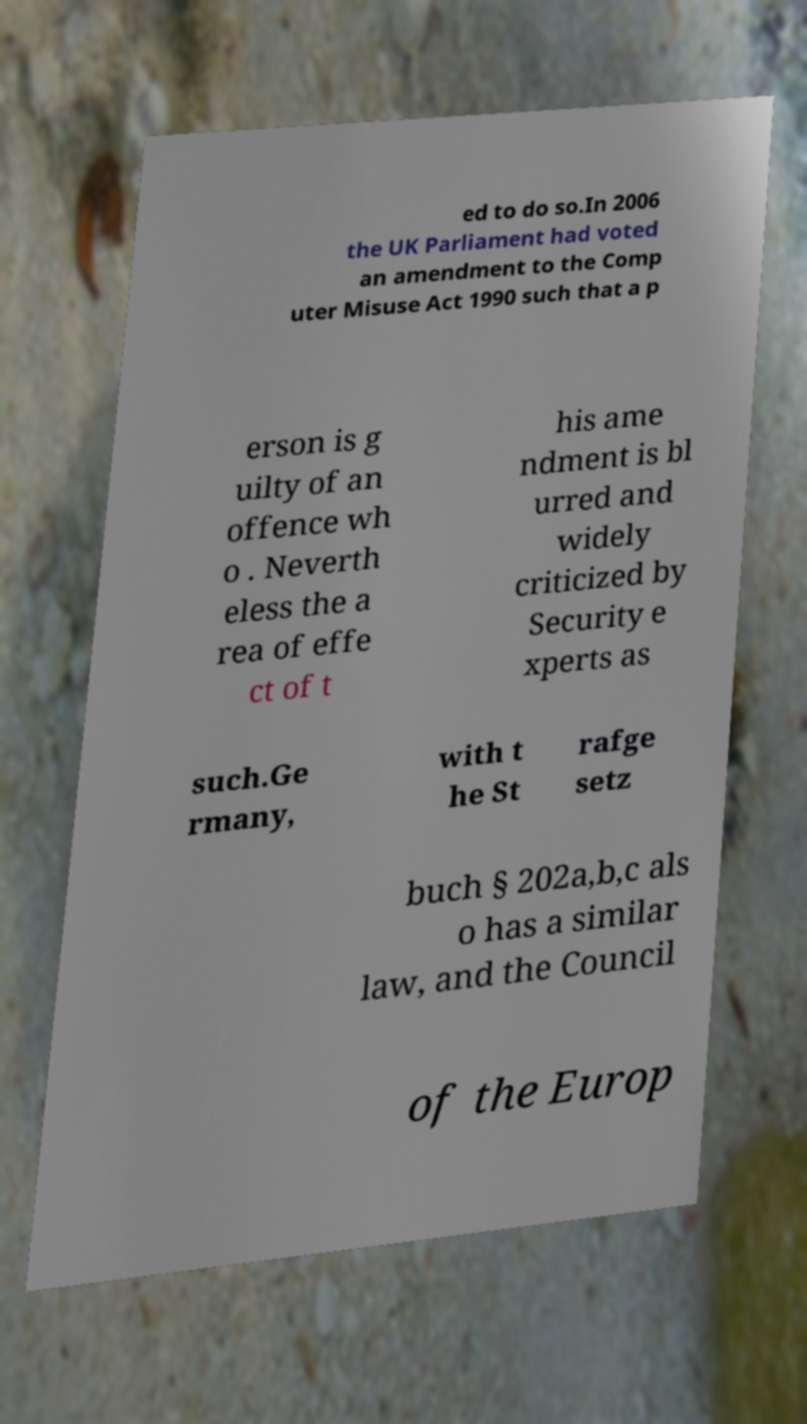Could you assist in decoding the text presented in this image and type it out clearly? ed to do so.In 2006 the UK Parliament had voted an amendment to the Comp uter Misuse Act 1990 such that a p erson is g uilty of an offence wh o . Neverth eless the a rea of effe ct of t his ame ndment is bl urred and widely criticized by Security e xperts as such.Ge rmany, with t he St rafge setz buch § 202a,b,c als o has a similar law, and the Council of the Europ 